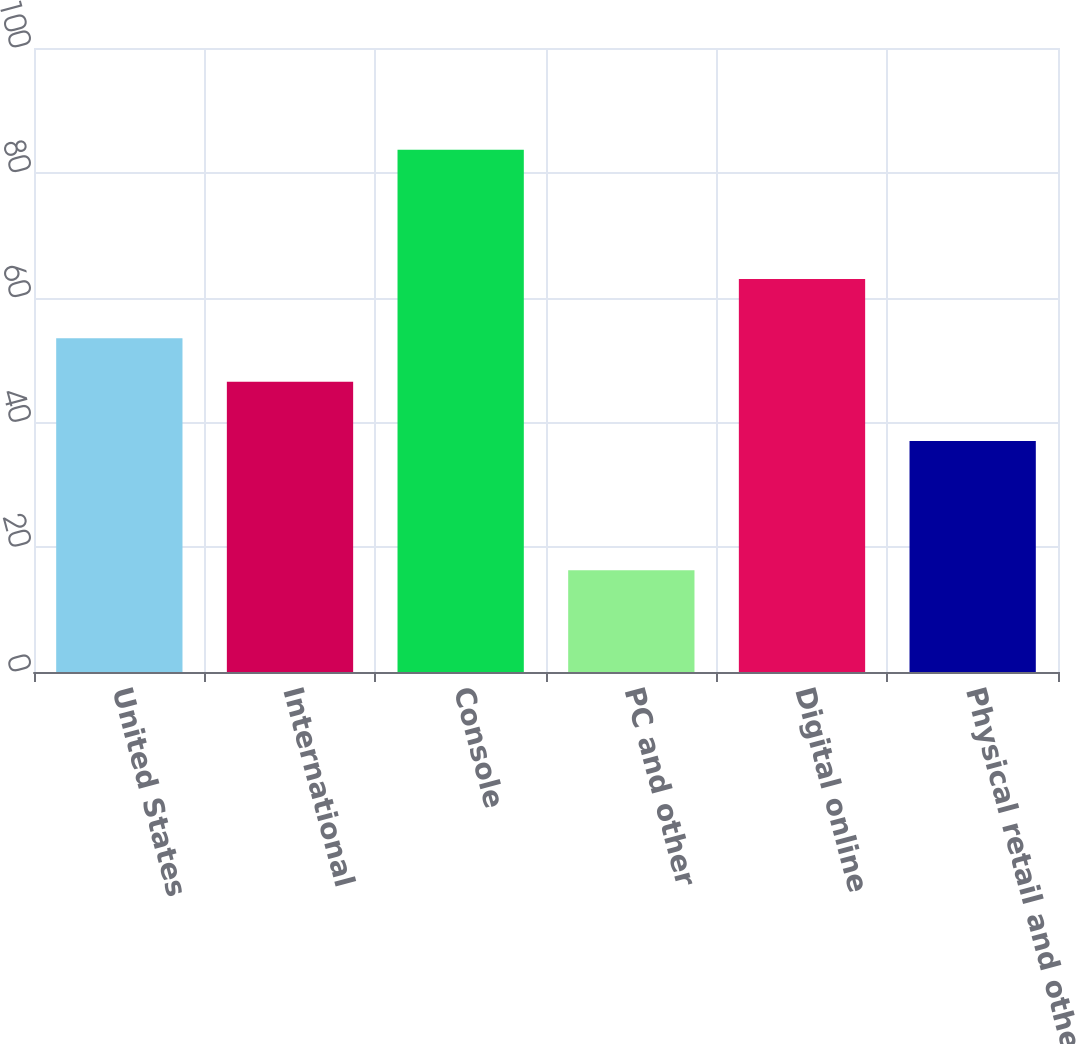<chart> <loc_0><loc_0><loc_500><loc_500><bar_chart><fcel>United States<fcel>International<fcel>Console<fcel>PC and other<fcel>Digital online<fcel>Physical retail and other<nl><fcel>53.5<fcel>46.5<fcel>83.7<fcel>16.3<fcel>63<fcel>37<nl></chart> 